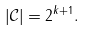<formula> <loc_0><loc_0><loc_500><loc_500>| \mathcal { C } | = 2 ^ { k + 1 } .</formula> 